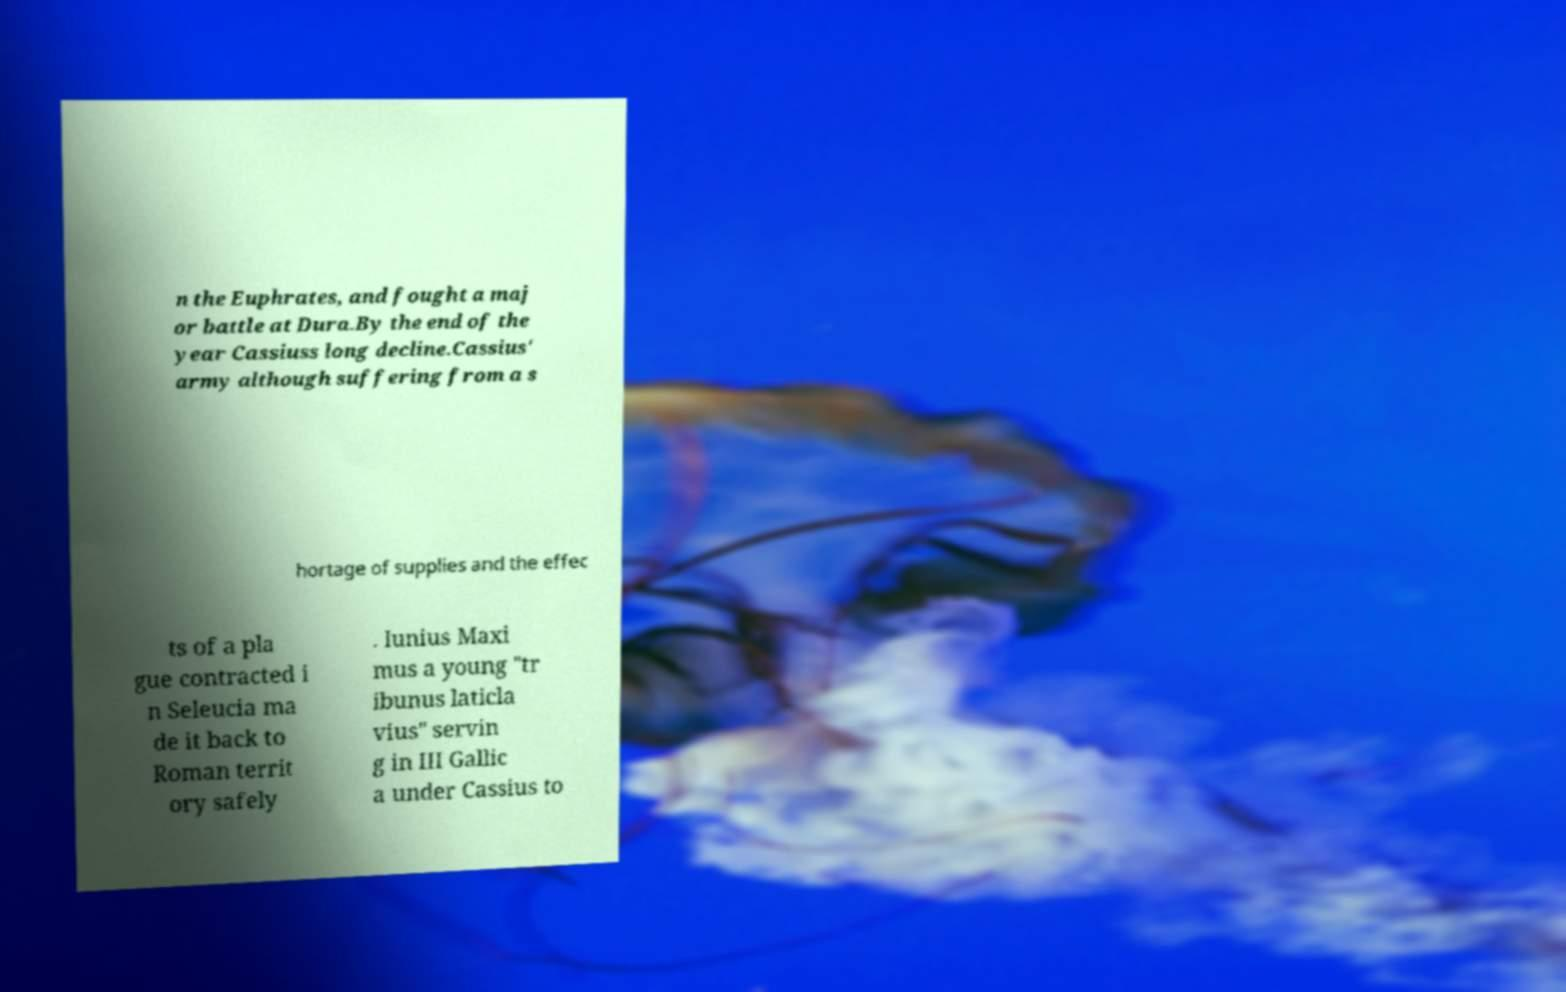Please identify and transcribe the text found in this image. n the Euphrates, and fought a maj or battle at Dura.By the end of the year Cassiuss long decline.Cassius' army although suffering from a s hortage of supplies and the effec ts of a pla gue contracted i n Seleucia ma de it back to Roman territ ory safely . Iunius Maxi mus a young "tr ibunus laticla vius" servin g in III Gallic a under Cassius to 